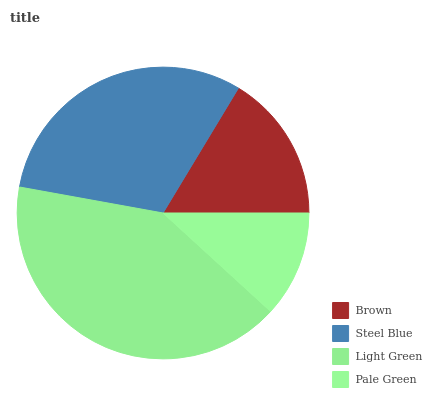Is Pale Green the minimum?
Answer yes or no. Yes. Is Light Green the maximum?
Answer yes or no. Yes. Is Steel Blue the minimum?
Answer yes or no. No. Is Steel Blue the maximum?
Answer yes or no. No. Is Steel Blue greater than Brown?
Answer yes or no. Yes. Is Brown less than Steel Blue?
Answer yes or no. Yes. Is Brown greater than Steel Blue?
Answer yes or no. No. Is Steel Blue less than Brown?
Answer yes or no. No. Is Steel Blue the high median?
Answer yes or no. Yes. Is Brown the low median?
Answer yes or no. Yes. Is Pale Green the high median?
Answer yes or no. No. Is Steel Blue the low median?
Answer yes or no. No. 